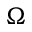Convert formula to latex. <formula><loc_0><loc_0><loc_500><loc_500>\Omega</formula> 